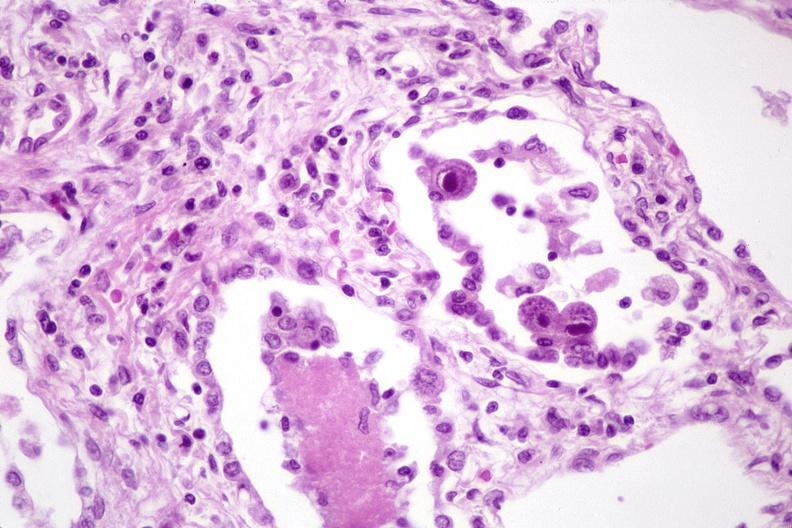does this image show lung, cyomegalovirus pneumonia and pneumocystis pneumonia?
Answer the question using a single word or phrase. Yes 